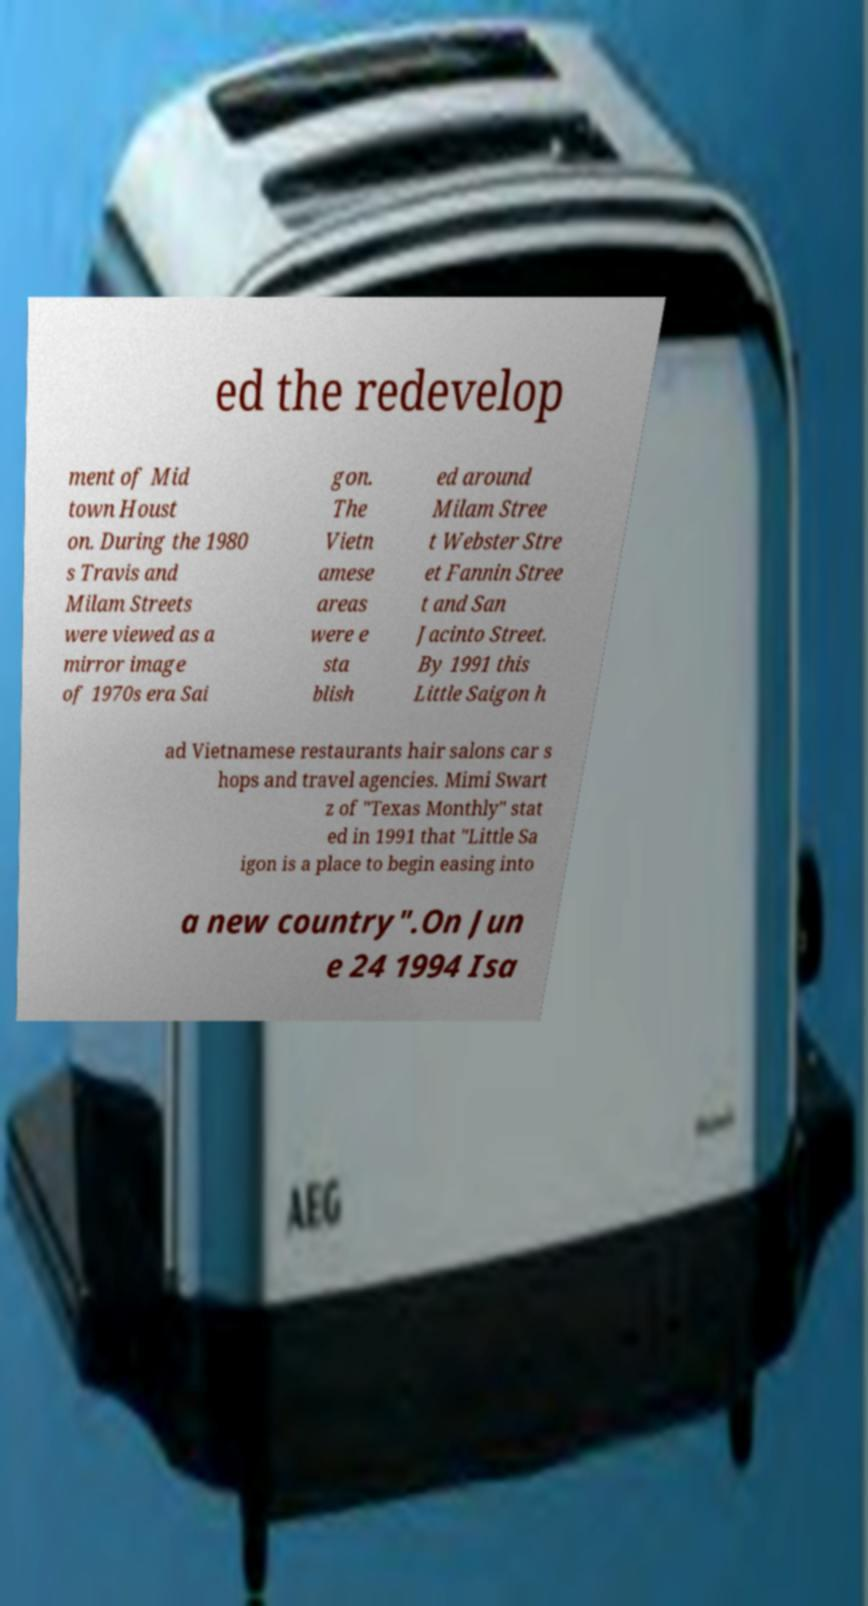Please read and relay the text visible in this image. What does it say? ed the redevelop ment of Mid town Houst on. During the 1980 s Travis and Milam Streets were viewed as a mirror image of 1970s era Sai gon. The Vietn amese areas were e sta blish ed around Milam Stree t Webster Stre et Fannin Stree t and San Jacinto Street. By 1991 this Little Saigon h ad Vietnamese restaurants hair salons car s hops and travel agencies. Mimi Swart z of "Texas Monthly" stat ed in 1991 that "Little Sa igon is a place to begin easing into a new country".On Jun e 24 1994 Isa 